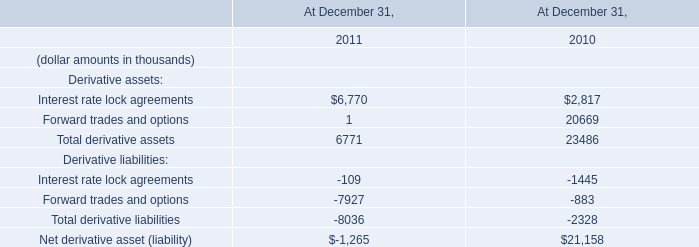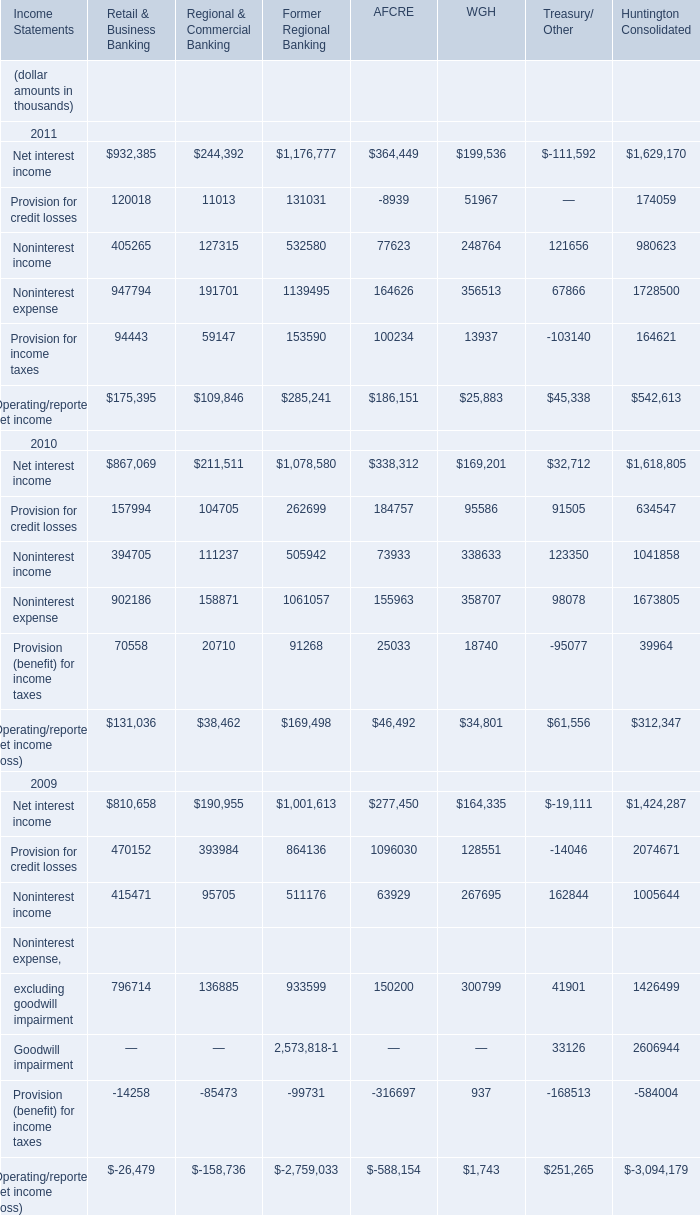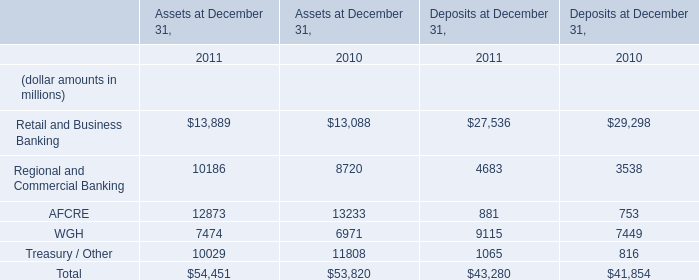In the year with largest amount of Net interest income, what's the sum of Provision for credit losses for Retail & Business Banking (in thousand) 
Computations: (((((120018 + 11013) + 131031) - 8939) + 51967) + 174059)
Answer: 479149.0. What was the average value of Retail and Business Banking, Regional and Commercial Banking, AFCRE in Assets at December 31, 2011 ? (in million) 
Computations: (((13889 + 10186) + 12873) / 3)
Answer: 12316.0. What is the total value of Net interest income, Provision for credit losses, Noninterest income and Noninterest expense in in 2011 for Retail & Business Banking ? (in thousand) 
Computations: (((932385 + 120018) + 405265) + 947794)
Answer: 2405462.0. 